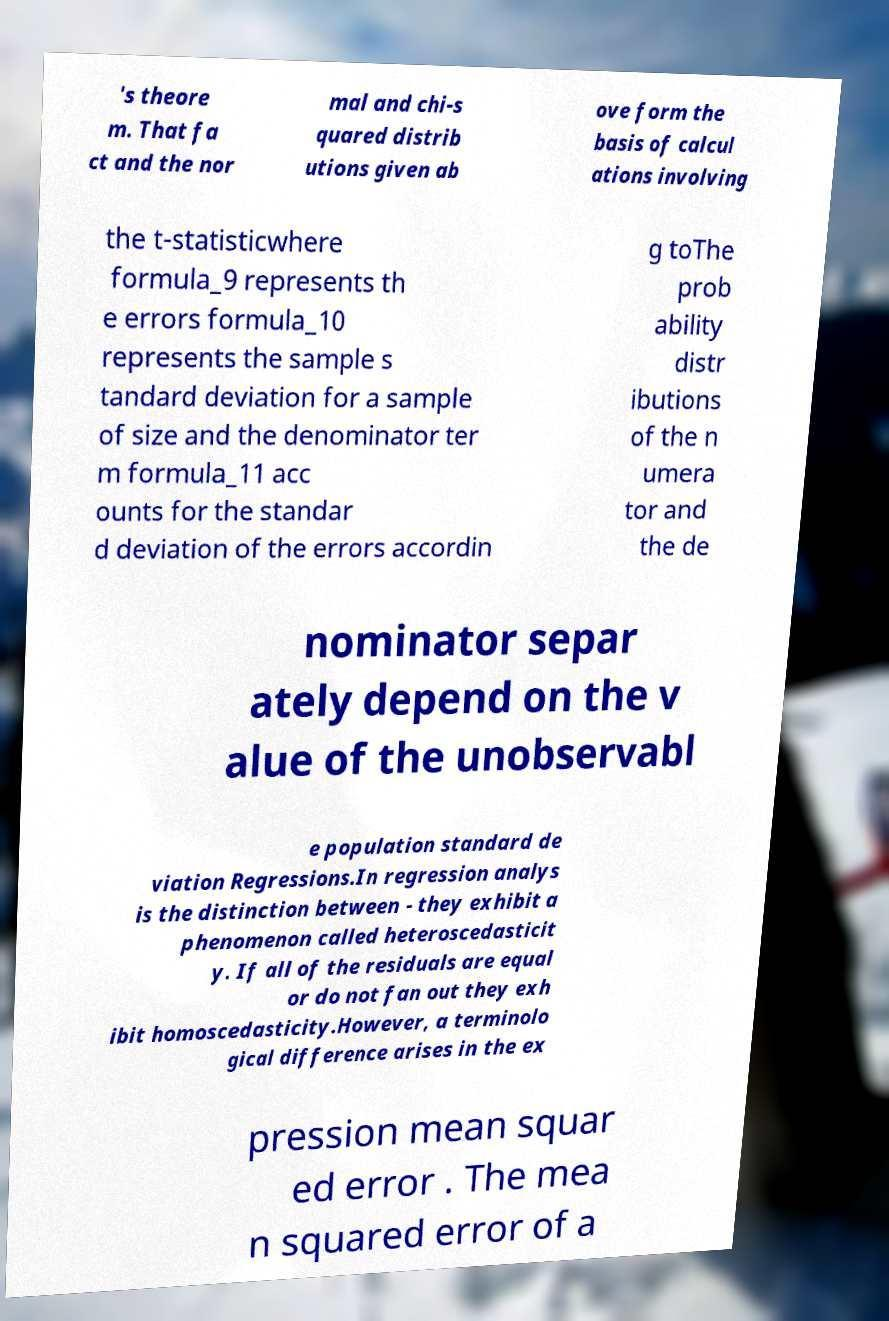What messages or text are displayed in this image? I need them in a readable, typed format. 's theore m. That fa ct and the nor mal and chi-s quared distrib utions given ab ove form the basis of calcul ations involving the t-statisticwhere formula_9 represents th e errors formula_10 represents the sample s tandard deviation for a sample of size and the denominator ter m formula_11 acc ounts for the standar d deviation of the errors accordin g toThe prob ability distr ibutions of the n umera tor and the de nominator separ ately depend on the v alue of the unobservabl e population standard de viation Regressions.In regression analys is the distinction between - they exhibit a phenomenon called heteroscedasticit y. If all of the residuals are equal or do not fan out they exh ibit homoscedasticity.However, a terminolo gical difference arises in the ex pression mean squar ed error . The mea n squared error of a 